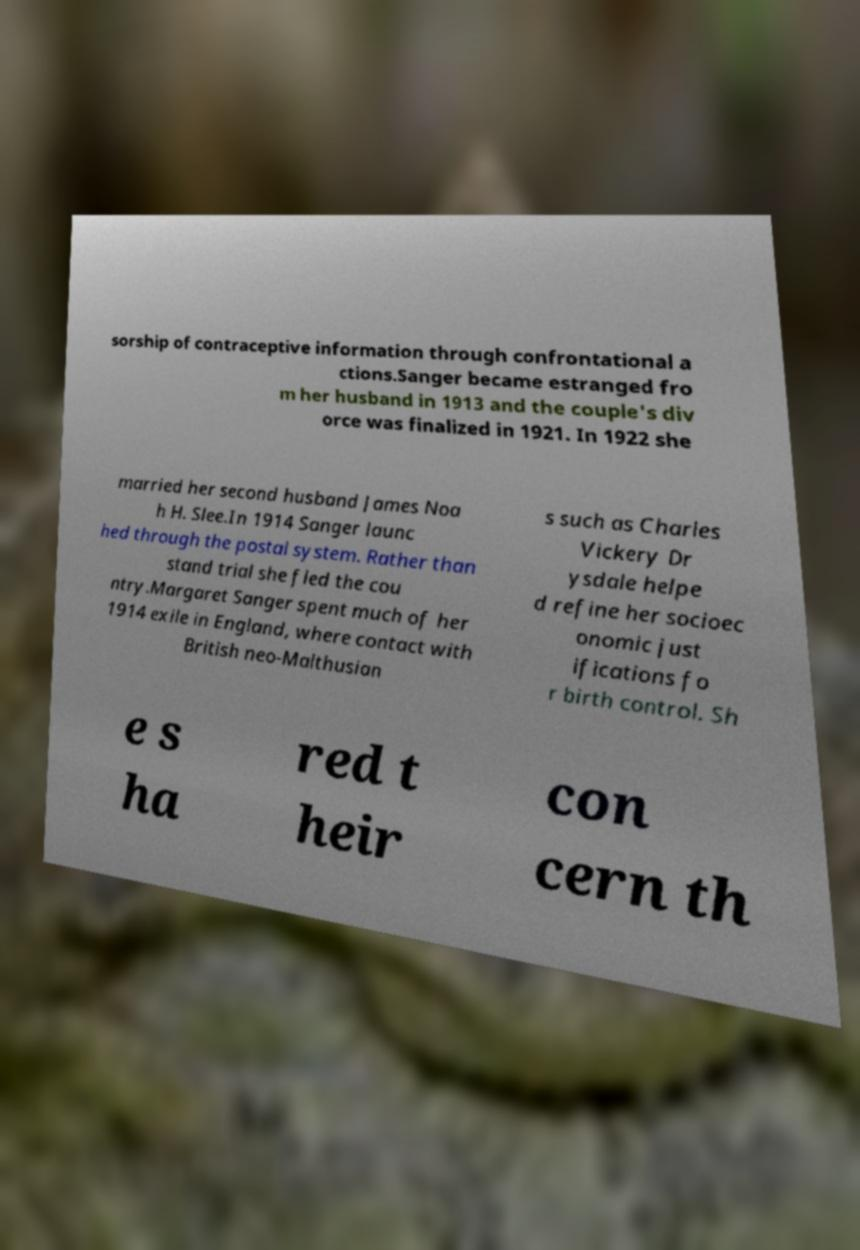For documentation purposes, I need the text within this image transcribed. Could you provide that? sorship of contraceptive information through confrontational a ctions.Sanger became estranged fro m her husband in 1913 and the couple's div orce was finalized in 1921. In 1922 she married her second husband James Noa h H. Slee.In 1914 Sanger launc hed through the postal system. Rather than stand trial she fled the cou ntry.Margaret Sanger spent much of her 1914 exile in England, where contact with British neo-Malthusian s such as Charles Vickery Dr ysdale helpe d refine her socioec onomic just ifications fo r birth control. Sh e s ha red t heir con cern th 